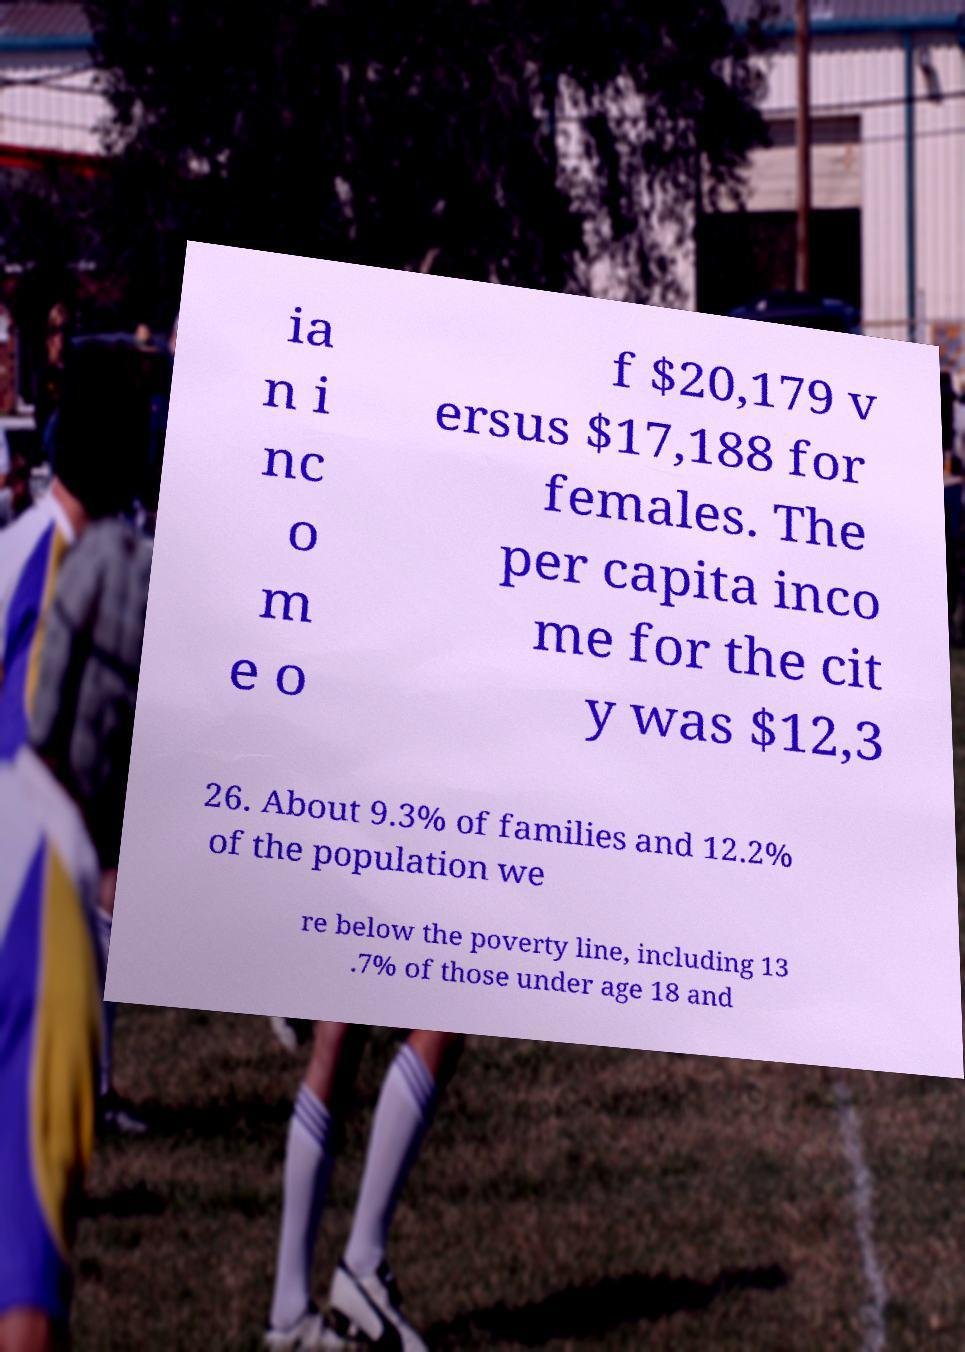Can you read and provide the text displayed in the image?This photo seems to have some interesting text. Can you extract and type it out for me? ia n i nc o m e o f $20,179 v ersus $17,188 for females. The per capita inco me for the cit y was $12,3 26. About 9.3% of families and 12.2% of the population we re below the poverty line, including 13 .7% of those under age 18 and 